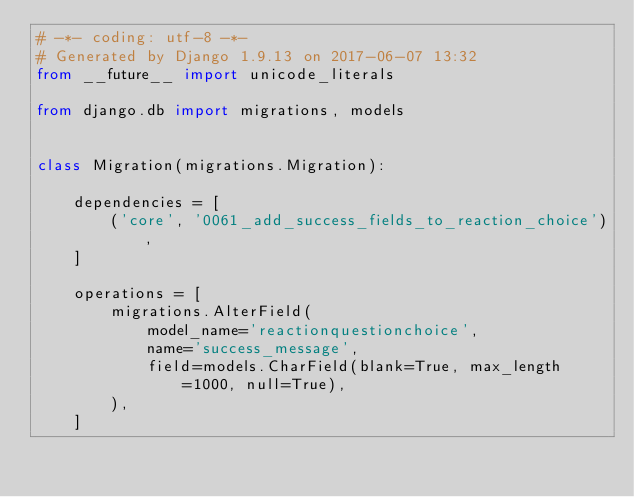Convert code to text. <code><loc_0><loc_0><loc_500><loc_500><_Python_># -*- coding: utf-8 -*-
# Generated by Django 1.9.13 on 2017-06-07 13:32
from __future__ import unicode_literals

from django.db import migrations, models


class Migration(migrations.Migration):

    dependencies = [
        ('core', '0061_add_success_fields_to_reaction_choice'),
    ]

    operations = [
        migrations.AlterField(
            model_name='reactionquestionchoice',
            name='success_message',
            field=models.CharField(blank=True, max_length=1000, null=True),
        ),
    ]
</code> 